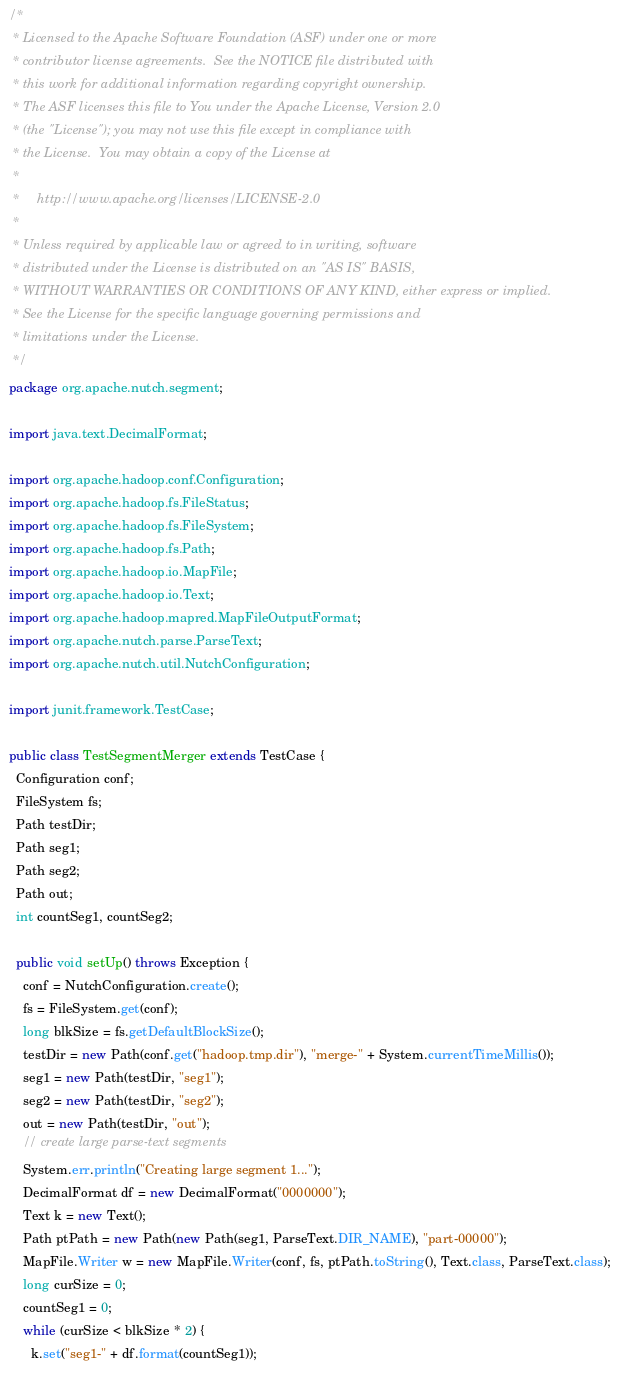<code> <loc_0><loc_0><loc_500><loc_500><_Java_>/*
 * Licensed to the Apache Software Foundation (ASF) under one or more
 * contributor license agreements.  See the NOTICE file distributed with
 * this work for additional information regarding copyright ownership.
 * The ASF licenses this file to You under the Apache License, Version 2.0
 * (the "License"); you may not use this file except in compliance with
 * the License.  You may obtain a copy of the License at
 *
 *     http://www.apache.org/licenses/LICENSE-2.0
 *
 * Unless required by applicable law or agreed to in writing, software
 * distributed under the License is distributed on an "AS IS" BASIS,
 * WITHOUT WARRANTIES OR CONDITIONS OF ANY KIND, either express or implied.
 * See the License for the specific language governing permissions and
 * limitations under the License.
 */
package org.apache.nutch.segment;

import java.text.DecimalFormat;

import org.apache.hadoop.conf.Configuration;
import org.apache.hadoop.fs.FileStatus;
import org.apache.hadoop.fs.FileSystem;
import org.apache.hadoop.fs.Path;
import org.apache.hadoop.io.MapFile;
import org.apache.hadoop.io.Text;
import org.apache.hadoop.mapred.MapFileOutputFormat;
import org.apache.nutch.parse.ParseText;
import org.apache.nutch.util.NutchConfiguration;

import junit.framework.TestCase;

public class TestSegmentMerger extends TestCase {
  Configuration conf;
  FileSystem fs;
  Path testDir;
  Path seg1;
  Path seg2;
  Path out;
  int countSeg1, countSeg2;
  
  public void setUp() throws Exception {
    conf = NutchConfiguration.create();
    fs = FileSystem.get(conf);
    long blkSize = fs.getDefaultBlockSize();
    testDir = new Path(conf.get("hadoop.tmp.dir"), "merge-" + System.currentTimeMillis());
    seg1 = new Path(testDir, "seg1");
    seg2 = new Path(testDir, "seg2");
    out = new Path(testDir, "out");
    // create large parse-text segments
    System.err.println("Creating large segment 1...");
    DecimalFormat df = new DecimalFormat("0000000");
    Text k = new Text();
    Path ptPath = new Path(new Path(seg1, ParseText.DIR_NAME), "part-00000");
    MapFile.Writer w = new MapFile.Writer(conf, fs, ptPath.toString(), Text.class, ParseText.class);
    long curSize = 0;
    countSeg1 = 0;
    while (curSize < blkSize * 2) {
      k.set("seg1-" + df.format(countSeg1));</code> 